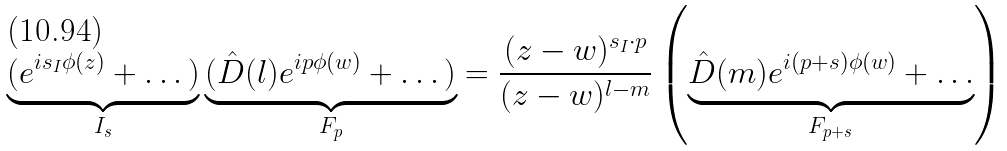Convert formula to latex. <formula><loc_0><loc_0><loc_500><loc_500>\underbrace { ( e ^ { i s _ { I } \phi ( z ) } + \dots ) } _ { I _ { s } } \underbrace { ( \hat { D } ( l ) e ^ { i p \phi ( w ) } + \dots ) } _ { F _ { p } } = \frac { ( z - w ) ^ { s _ { I } \cdot p } } { ( z - w ) ^ { l - m } } \left ( \underbrace { \hat { D } ( m ) e ^ { i ( p + s ) \phi ( w ) } + \dots } _ { F _ { p + s } } \right )</formula> 